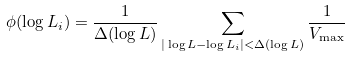Convert formula to latex. <formula><loc_0><loc_0><loc_500><loc_500>\phi ( \log L _ { i } ) = \frac { 1 } { \Delta ( \log L ) } \sum _ { | \log L - \log L _ { i } | < \Delta ( \log L ) } \frac { 1 } { V _ { \max } }</formula> 